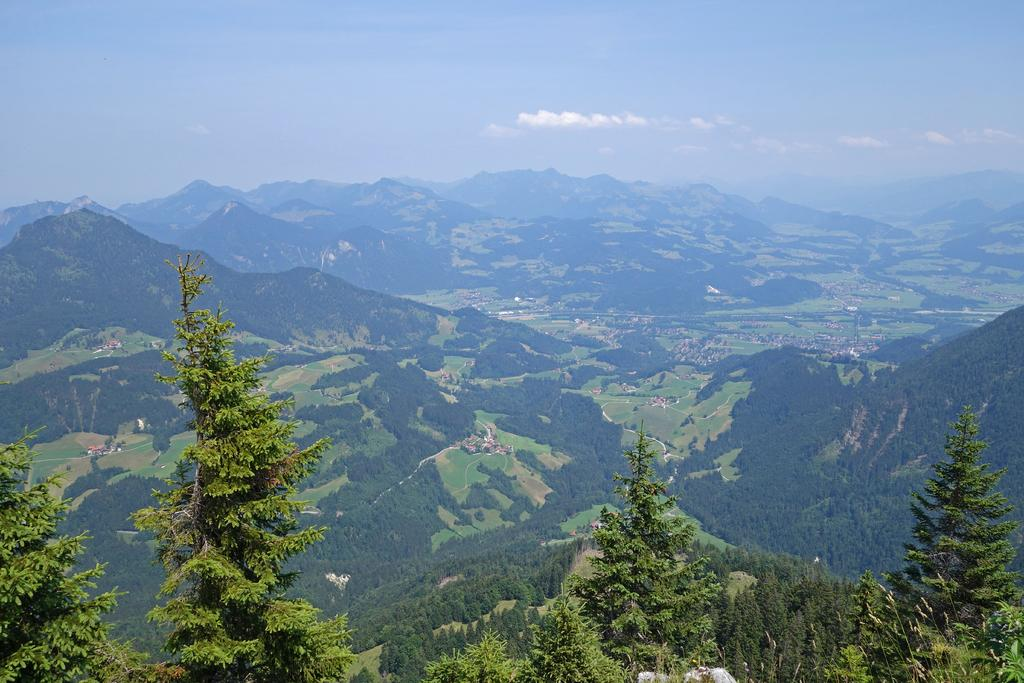What type of natural features can be seen in the image? There are trees and mountains in the image. How are the mountains characterized in the image? The mountains are covered with trees. What is the condition of the sky in the image? The sky is clear in the image. What language is spoken by the scarecrow in the image? There is no scarecrow present in the image, so it is not possible to determine what language it might speak. How many oranges are visible on the trees in the image? There are no oranges visible in the image; it features trees and mountains. 